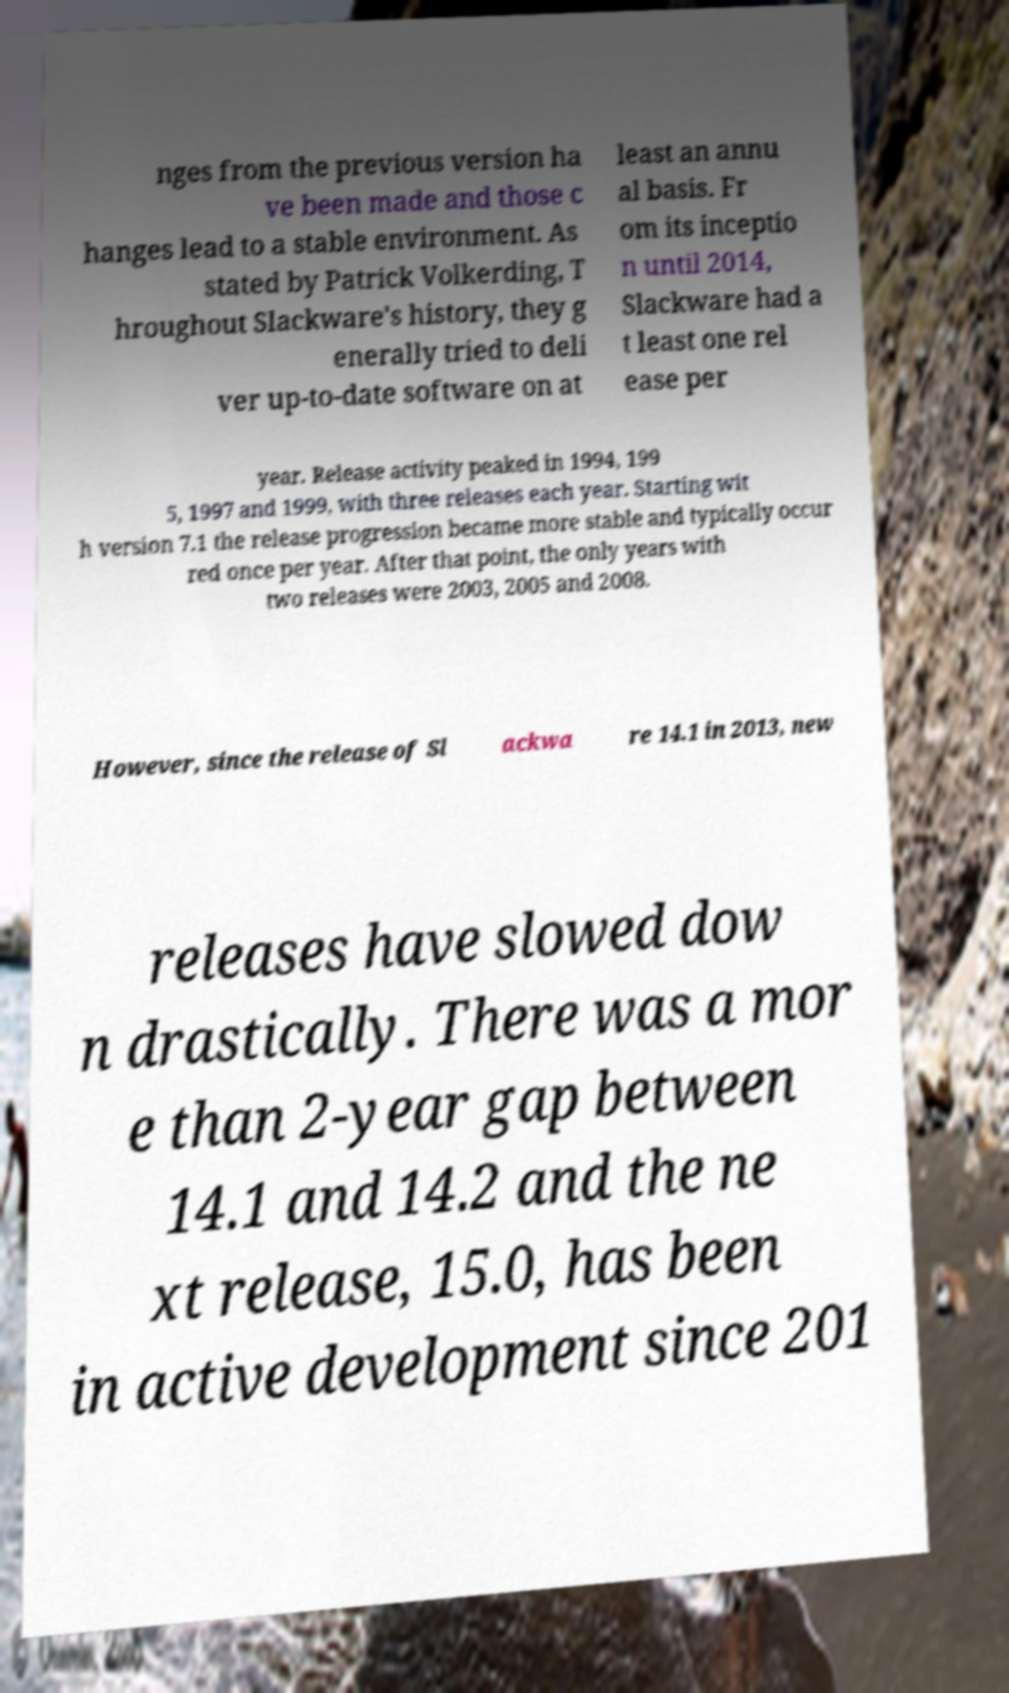Could you assist in decoding the text presented in this image and type it out clearly? nges from the previous version ha ve been made and those c hanges lead to a stable environment. As stated by Patrick Volkerding, T hroughout Slackware's history, they g enerally tried to deli ver up-to-date software on at least an annu al basis. Fr om its inceptio n until 2014, Slackware had a t least one rel ease per year. Release activity peaked in 1994, 199 5, 1997 and 1999, with three releases each year. Starting wit h version 7.1 the release progression became more stable and typically occur red once per year. After that point, the only years with two releases were 2003, 2005 and 2008. However, since the release of Sl ackwa re 14.1 in 2013, new releases have slowed dow n drastically. There was a mor e than 2-year gap between 14.1 and 14.2 and the ne xt release, 15.0, has been in active development since 201 